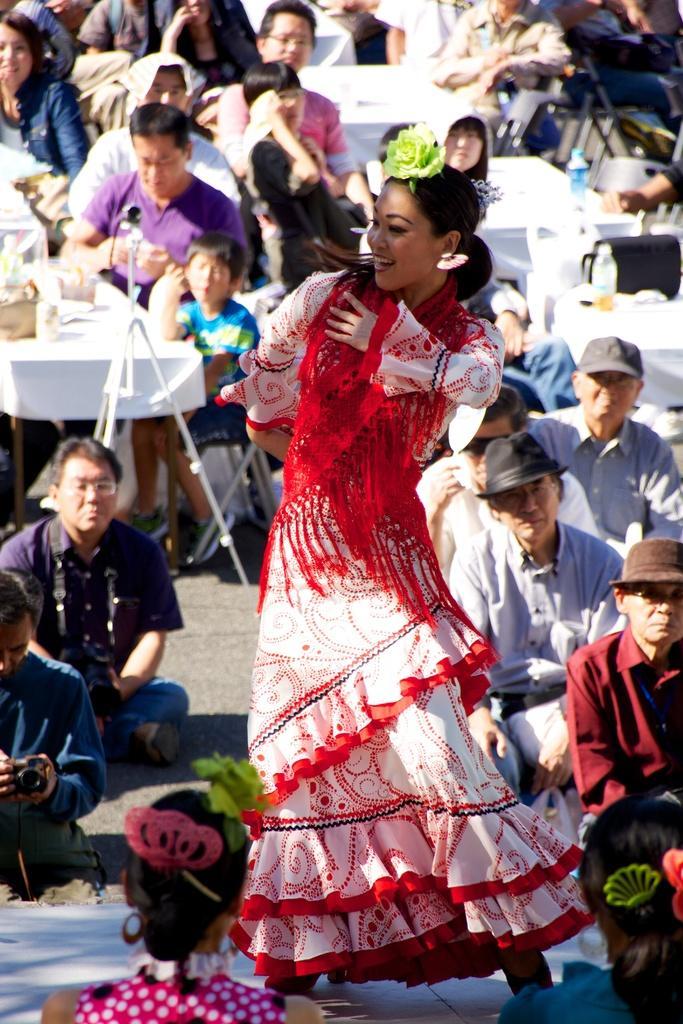Describe this image in one or two sentences. In this picture there is a woman who is dancing, beside her I can see some people were sitting on the ground and watching the dance. At the top I can see many people were sitting on the chair near to the table. On the left I can see the glass, cotton box and other objects on the table. On the right background I can see some peoples were holding a camera. 